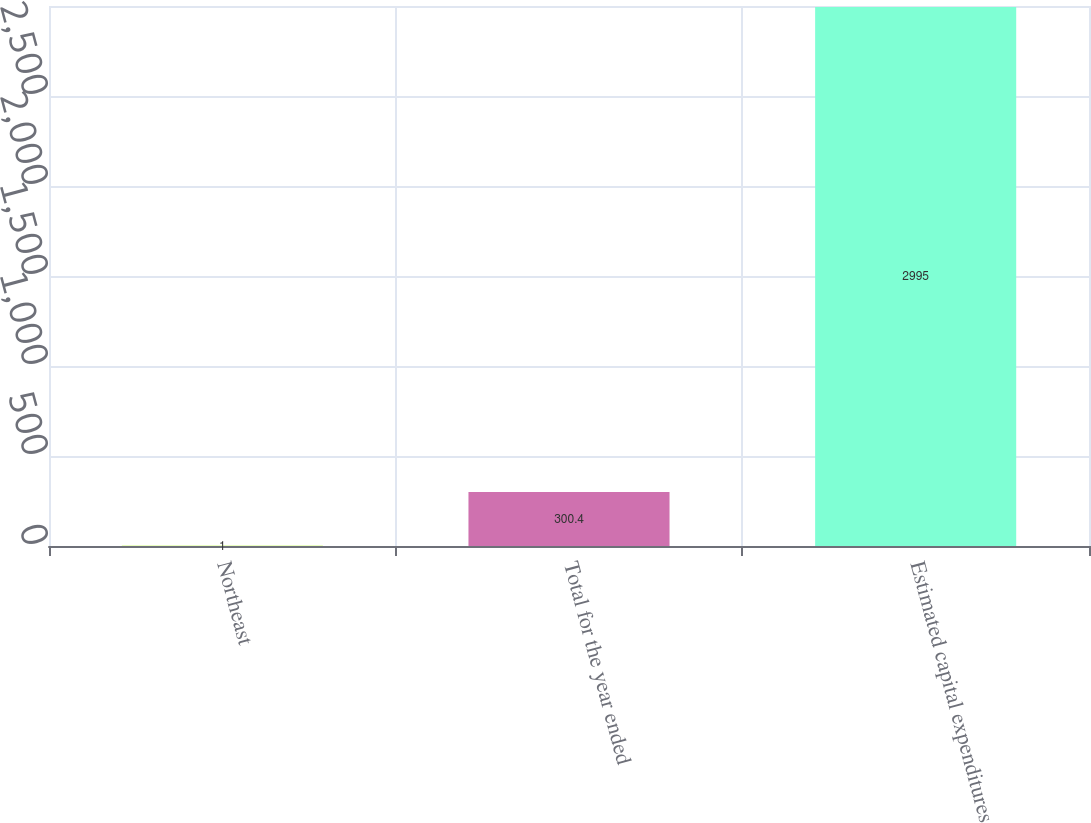Convert chart. <chart><loc_0><loc_0><loc_500><loc_500><bar_chart><fcel>Northeast<fcel>Total for the year ended<fcel>Estimated capital expenditures<nl><fcel>1<fcel>300.4<fcel>2995<nl></chart> 